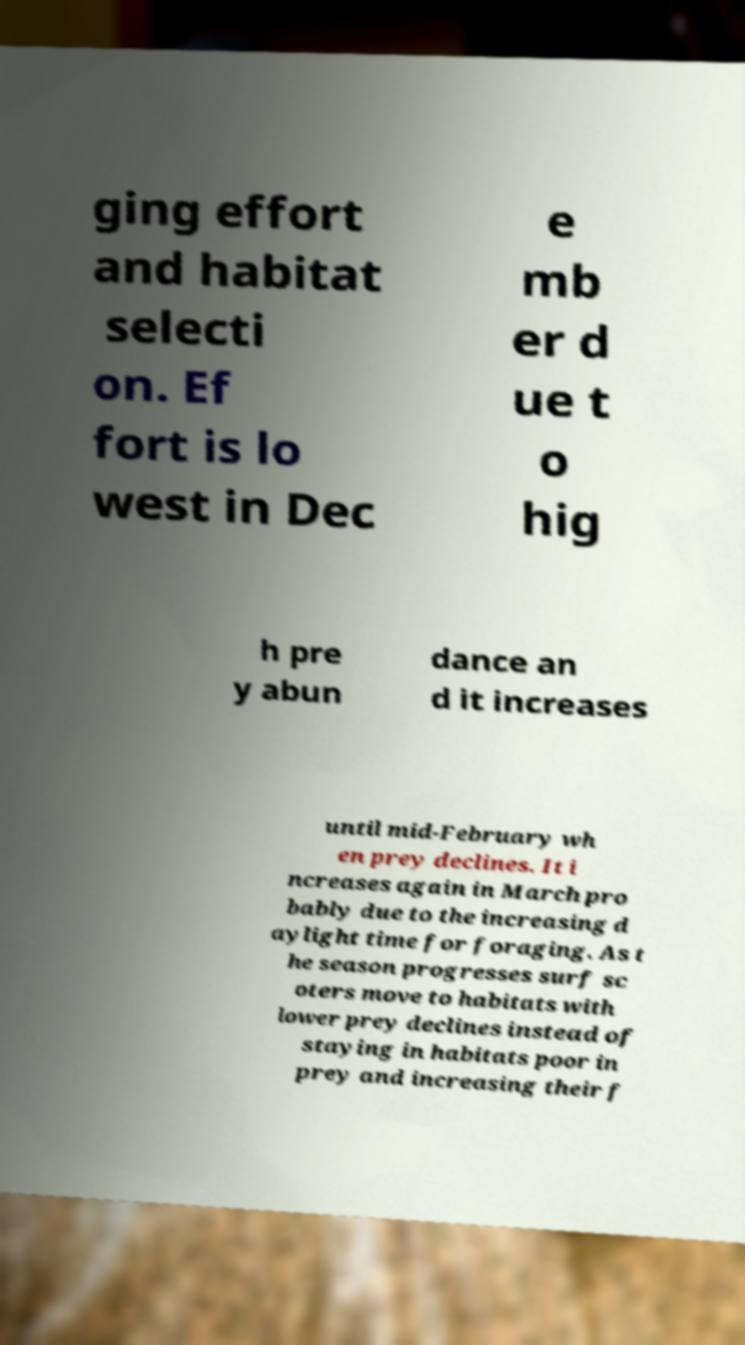Could you extract and type out the text from this image? ging effort and habitat selecti on. Ef fort is lo west in Dec e mb er d ue t o hig h pre y abun dance an d it increases until mid-February wh en prey declines. It i ncreases again in March pro bably due to the increasing d aylight time for foraging. As t he season progresses surf sc oters move to habitats with lower prey declines instead of staying in habitats poor in prey and increasing their f 